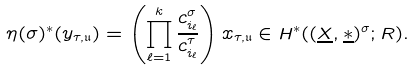<formula> <loc_0><loc_0><loc_500><loc_500>\eta ( \sigma ) ^ { * } ( y _ { \tau , \mathfrak { u } } ) = \left ( \prod ^ { k } _ { \ell = 1 } \frac { c _ { i _ { \ell } } ^ { \sigma } } { c _ { i _ { \ell } } ^ { \tau } } \right ) x _ { \tau , \mathfrak { u } } \in H ^ { * } ( ( \underline { X } , \underline { \ast } ) ^ { \sigma } ; R ) .</formula> 